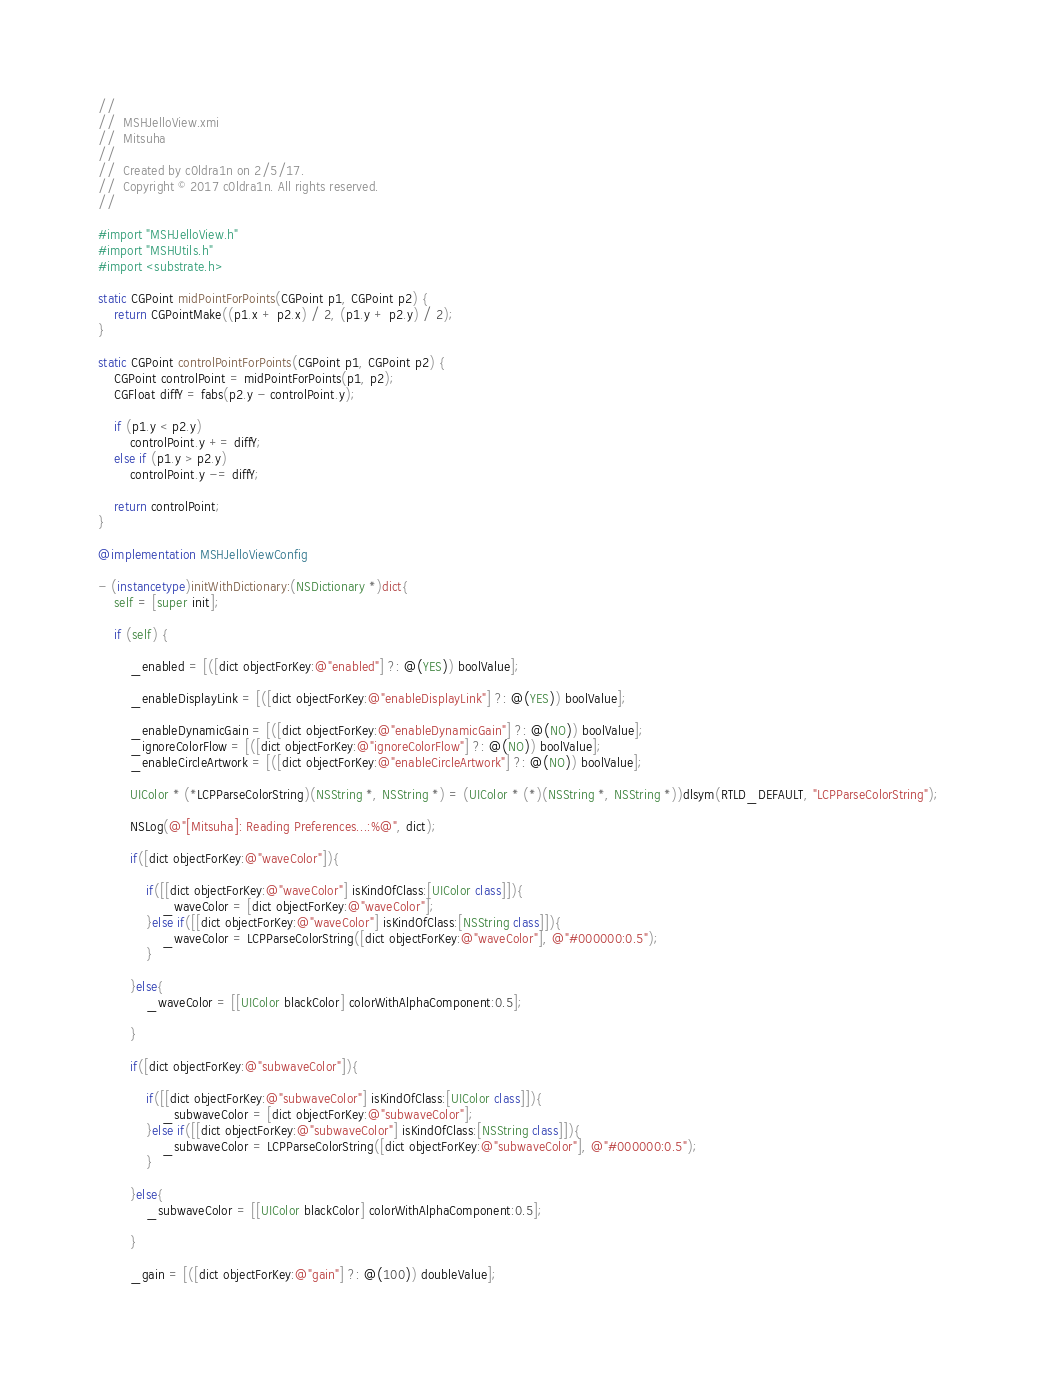Convert code to text. <code><loc_0><loc_0><loc_500><loc_500><_ObjectiveC_>//
//  MSHJelloView.xmi
//  Mitsuha
//
//  Created by c0ldra1n on 2/5/17.
//  Copyright © 2017 c0ldra1n. All rights reserved.
//

#import "MSHJelloView.h"
#import "MSHUtils.h"
#import <substrate.h>

static CGPoint midPointForPoints(CGPoint p1, CGPoint p2) {
    return CGPointMake((p1.x + p2.x) / 2, (p1.y + p2.y) / 2);
}

static CGPoint controlPointForPoints(CGPoint p1, CGPoint p2) {
    CGPoint controlPoint = midPointForPoints(p1, p2);
    CGFloat diffY = fabs(p2.y - controlPoint.y);
    
    if (p1.y < p2.y)
        controlPoint.y += diffY;
    else if (p1.y > p2.y)
        controlPoint.y -= diffY;
    
    return controlPoint;
}

@implementation MSHJelloViewConfig

- (instancetype)initWithDictionary:(NSDictionary *)dict{
    self = [super init];
    
    if (self) {
        
        _enabled = [([dict objectForKey:@"enabled"] ?: @(YES)) boolValue];
        
        _enableDisplayLink = [([dict objectForKey:@"enableDisplayLink"] ?: @(YES)) boolValue];
        
        _enableDynamicGain = [([dict objectForKey:@"enableDynamicGain"] ?: @(NO)) boolValue];
        _ignoreColorFlow = [([dict objectForKey:@"ignoreColorFlow"] ?: @(NO)) boolValue];
        _enableCircleArtwork = [([dict objectForKey:@"enableCircleArtwork"] ?: @(NO)) boolValue];
        
        UIColor * (*LCPParseColorString)(NSString *, NSString *) = (UIColor * (*)(NSString *, NSString *))dlsym(RTLD_DEFAULT, "LCPParseColorString");
        
        NSLog(@"[Mitsuha]: Reading Preferences...:%@", dict);
        
        if([dict objectForKey:@"waveColor"]){
            
            if([[dict objectForKey:@"waveColor"] isKindOfClass:[UIColor class]]){
                _waveColor = [dict objectForKey:@"waveColor"];
            }else if([[dict objectForKey:@"waveColor"] isKindOfClass:[NSString class]]){
                _waveColor = LCPParseColorString([dict objectForKey:@"waveColor"], @"#000000:0.5");
            }
            
        }else{
            _waveColor = [[UIColor blackColor] colorWithAlphaComponent:0.5];
            
        }
        
        if([dict objectForKey:@"subwaveColor"]){
            
            if([[dict objectForKey:@"subwaveColor"] isKindOfClass:[UIColor class]]){
                _subwaveColor = [dict objectForKey:@"subwaveColor"];
            }else if([[dict objectForKey:@"subwaveColor"] isKindOfClass:[NSString class]]){
                _subwaveColor = LCPParseColorString([dict objectForKey:@"subwaveColor"], @"#000000:0.5");
            }
            
        }else{
            _subwaveColor = [[UIColor blackColor] colorWithAlphaComponent:0.5];
            
        }
        
        _gain = [([dict objectForKey:@"gain"] ?: @(100)) doubleValue];</code> 